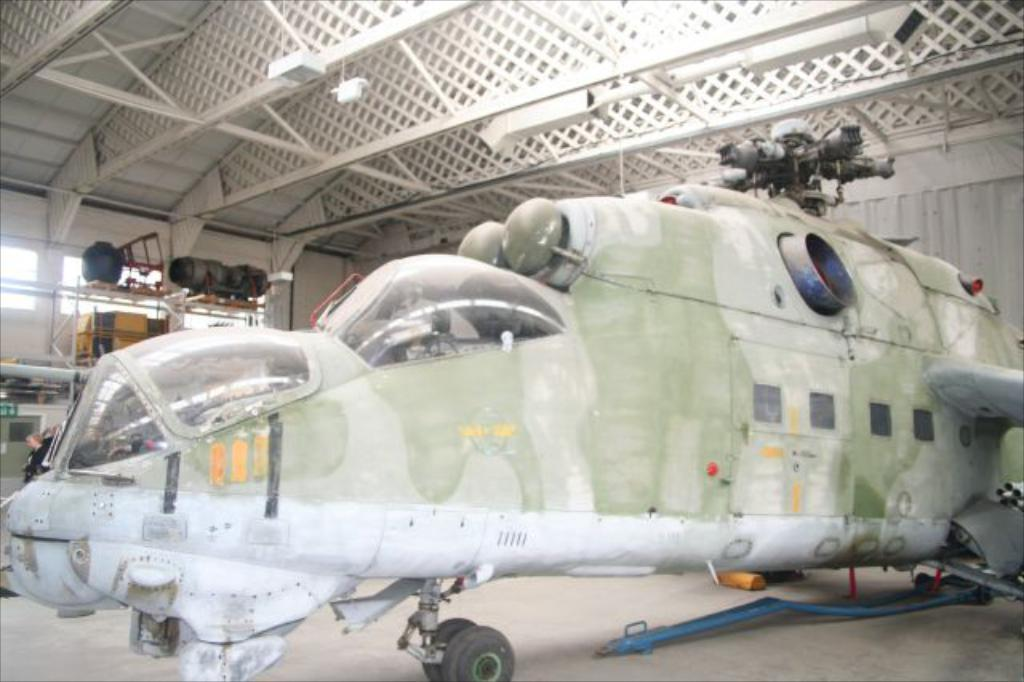What is the main subject of the image? The main subject of the image is a plane. What else can be seen in the image besides the plane? There is a wall, windows, and lights visible in the image. What type of oil is being used to drive the plane in the image? There is no indication of the plane being driven by oil or any other fuel in the image. 